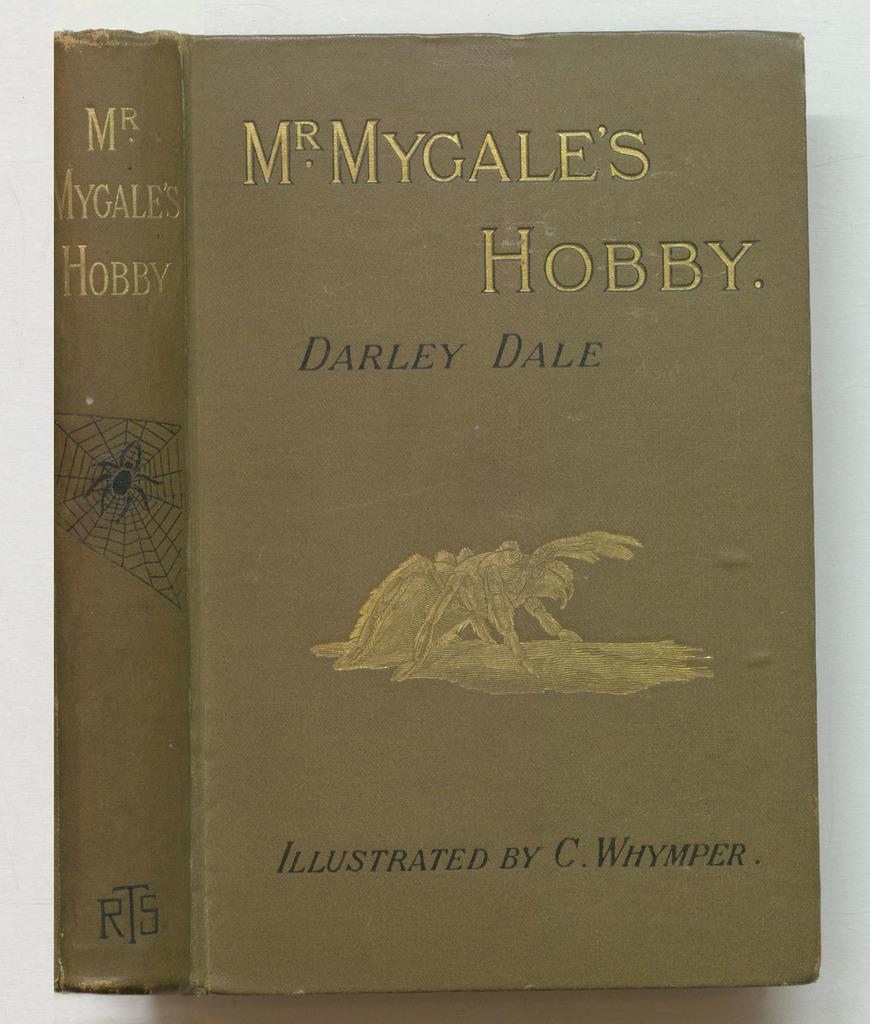Who illustrated this book?
Your answer should be compact. C. whymper. Who wrote this book?
Your answer should be very brief. Darley dale. 